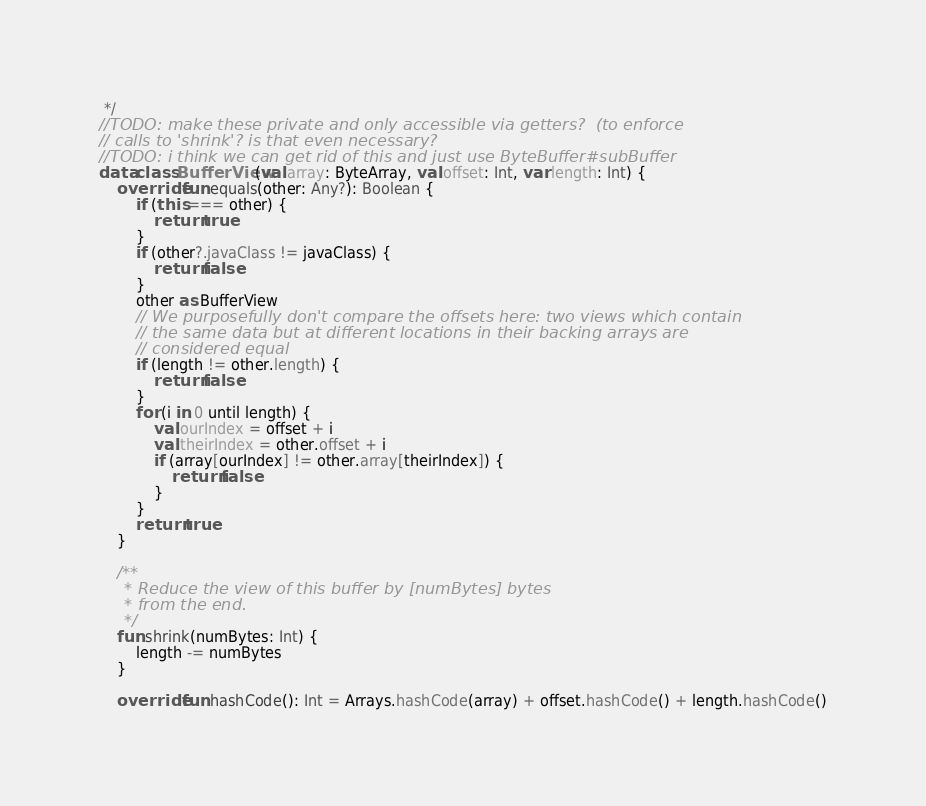<code> <loc_0><loc_0><loc_500><loc_500><_Kotlin_> */
//TODO: make these private and only accessible via getters?  (to enforce
// calls to 'shrink'? is that even necessary?
//TODO: i think we can get rid of this and just use ByteBuffer#subBuffer
data class BufferView(val array: ByteArray, val offset: Int, var length: Int) {
    override fun equals(other: Any?): Boolean {
        if (this === other) {
            return true
        }
        if (other?.javaClass != javaClass) {
            return false
        }
        other as BufferView
        // We purposefully don't compare the offsets here: two views which contain
        // the same data but at different locations in their backing arrays are
        // considered equal
        if (length != other.length) {
            return false
        }
        for (i in 0 until length) {
            val ourIndex = offset + i
            val theirIndex = other.offset + i
            if (array[ourIndex] != other.array[theirIndex]) {
                return false
            }
        }
        return true
    }

    /**
     * Reduce the view of this buffer by [numBytes] bytes
     * from the end.
     */
    fun shrink(numBytes: Int) {
        length -= numBytes
    }

    override fun hashCode(): Int = Arrays.hashCode(array) + offset.hashCode() + length.hashCode()
</code> 